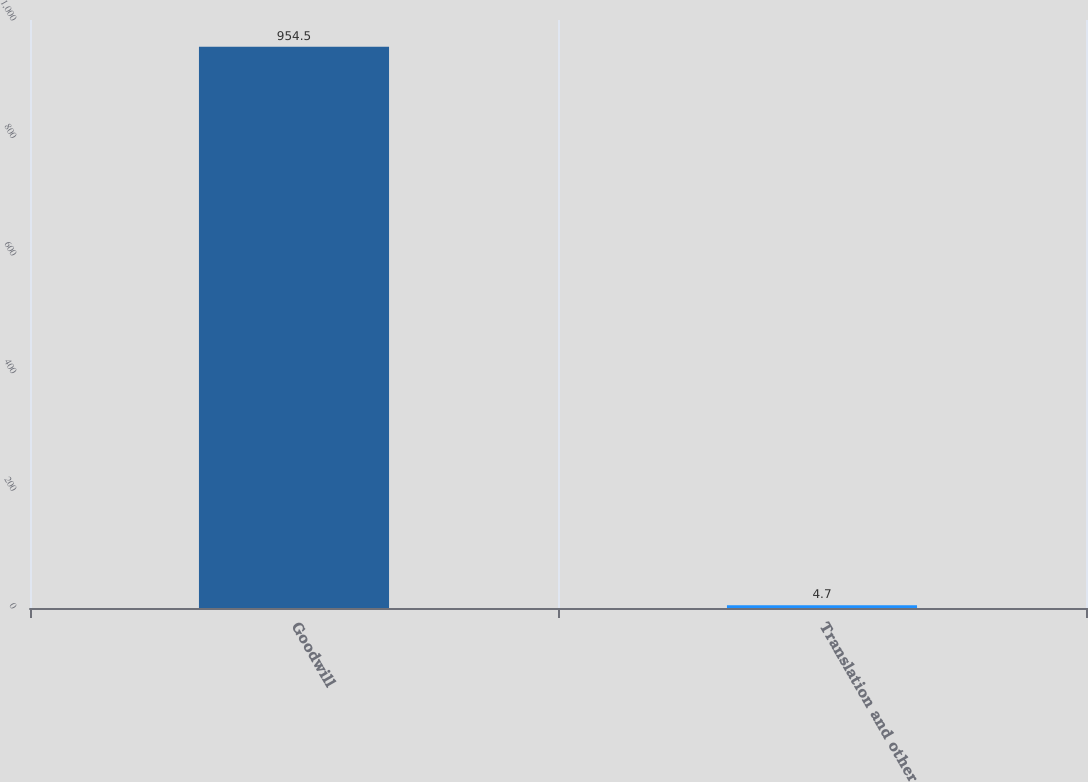Convert chart. <chart><loc_0><loc_0><loc_500><loc_500><bar_chart><fcel>Goodwill<fcel>Translation and other<nl><fcel>954.5<fcel>4.7<nl></chart> 